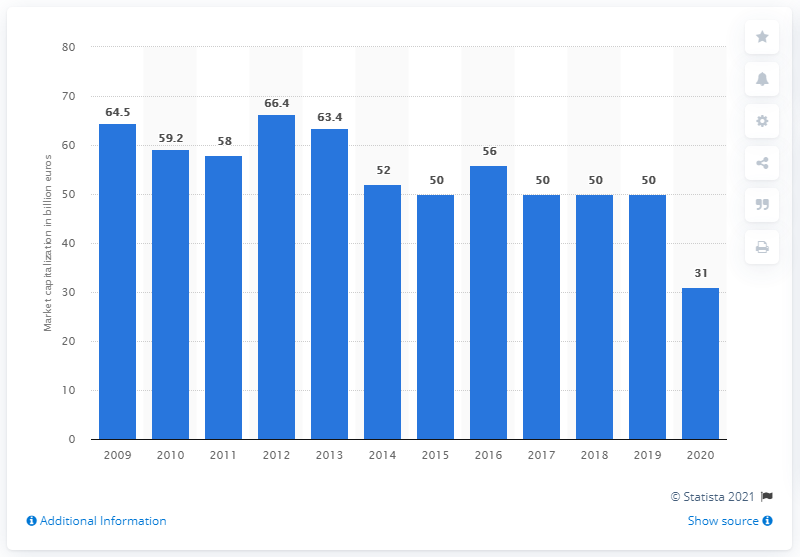Outline some significant characteristics in this image. Eni's market capitalization in 2020 was approximately 31. 